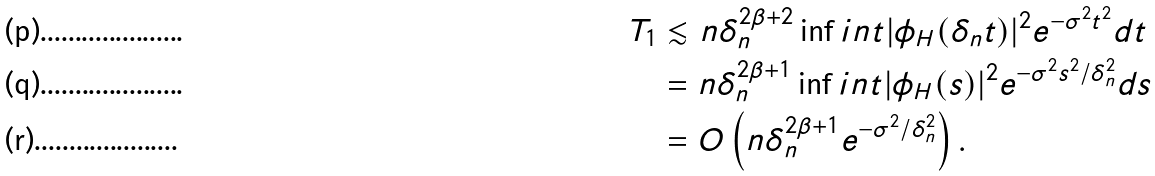Convert formula to latex. <formula><loc_0><loc_0><loc_500><loc_500>T _ { 1 } & \lesssim n \delta _ { n } ^ { 2 \beta + 2 } \inf i n t | \phi _ { H } ( \delta _ { n } t ) | ^ { 2 } e ^ { - \sigma ^ { 2 } t ^ { 2 } } d t \\ & = n \delta _ { n } ^ { 2 \beta + 1 } \inf i n t | \phi _ { H } ( s ) | ^ { 2 } e ^ { - \sigma ^ { 2 } s ^ { 2 } / \delta _ { n } ^ { 2 } } d s \\ & = O \left ( n \delta _ { n } ^ { 2 \beta + 1 } e ^ { - \sigma ^ { 2 } / \delta _ { n } ^ { 2 } } \right ) .</formula> 